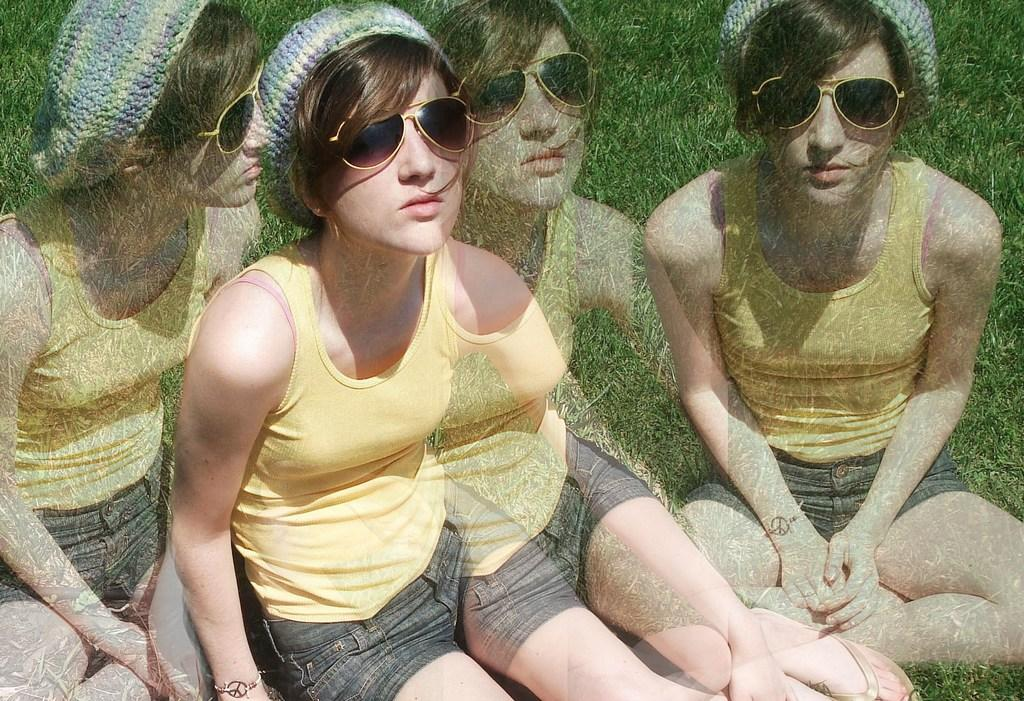How was the image altered or modified? The image is edited. What can be seen in the reflection of the image? There is a reflection of a person in the image. What type of vegetation is present at the bottom of the image? There is grass at the bottom of the image. What type of sail can be seen on the grass in the image? There is no sail present in the image, and the grass is not associated with any sail. 